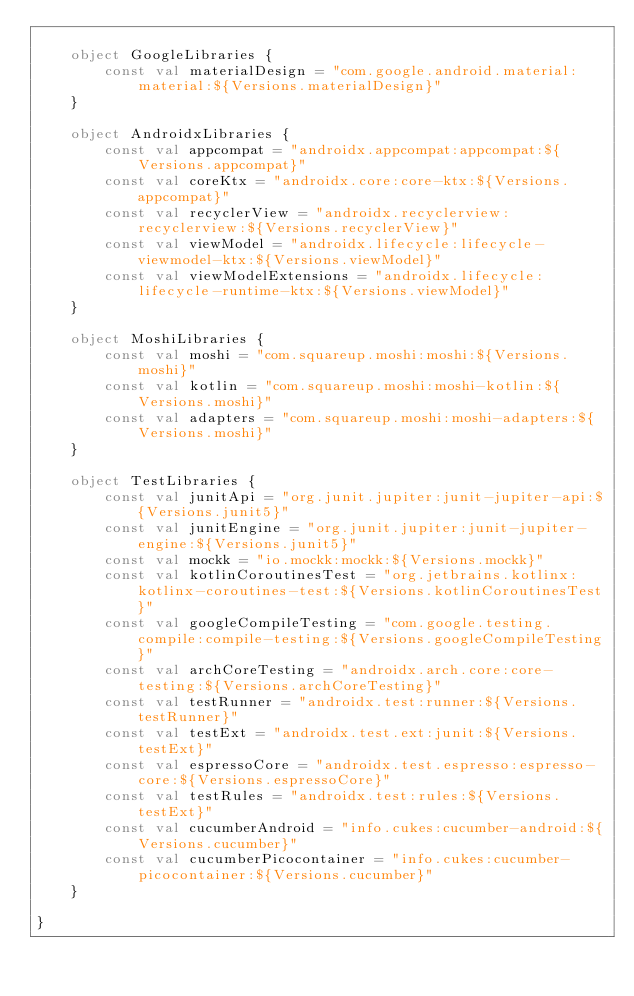<code> <loc_0><loc_0><loc_500><loc_500><_Kotlin_>
    object GoogleLibraries {
        const val materialDesign = "com.google.android.material:material:${Versions.materialDesign}"
    }

    object AndroidxLibraries {
        const val appcompat = "androidx.appcompat:appcompat:${Versions.appcompat}"
        const val coreKtx = "androidx.core:core-ktx:${Versions.appcompat}"
        const val recyclerView = "androidx.recyclerview:recyclerview:${Versions.recyclerView}"
        const val viewModel = "androidx.lifecycle:lifecycle-viewmodel-ktx:${Versions.viewModel}"
        const val viewModelExtensions = "androidx.lifecycle:lifecycle-runtime-ktx:${Versions.viewModel}"
    }

    object MoshiLibraries {
        const val moshi = "com.squareup.moshi:moshi:${Versions.moshi}"
        const val kotlin = "com.squareup.moshi:moshi-kotlin:${Versions.moshi}"
        const val adapters = "com.squareup.moshi:moshi-adapters:${Versions.moshi}"
    }

    object TestLibraries {
        const val junitApi = "org.junit.jupiter:junit-jupiter-api:${Versions.junit5}"
        const val junitEngine = "org.junit.jupiter:junit-jupiter-engine:${Versions.junit5}"
        const val mockk = "io.mockk:mockk:${Versions.mockk}"
        const val kotlinCoroutinesTest = "org.jetbrains.kotlinx:kotlinx-coroutines-test:${Versions.kotlinCoroutinesTest}"
        const val googleCompileTesting = "com.google.testing.compile:compile-testing:${Versions.googleCompileTesting}"
        const val archCoreTesting = "androidx.arch.core:core-testing:${Versions.archCoreTesting}"
        const val testRunner = "androidx.test:runner:${Versions.testRunner}"
        const val testExt = "androidx.test.ext:junit:${Versions.testExt}"
        const val espressoCore = "androidx.test.espresso:espresso-core:${Versions.espressoCore}"
        const val testRules = "androidx.test:rules:${Versions.testExt}"
        const val cucumberAndroid = "info.cukes:cucumber-android:${Versions.cucumber}"
        const val cucumberPicocontainer = "info.cukes:cucumber-picocontainer:${Versions.cucumber}"
    }

}</code> 